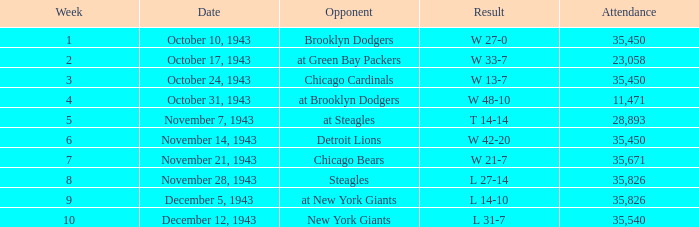What is the smallest attendance for a week fewer than 4, with w 13-7 as the outcome? 35450.0. 